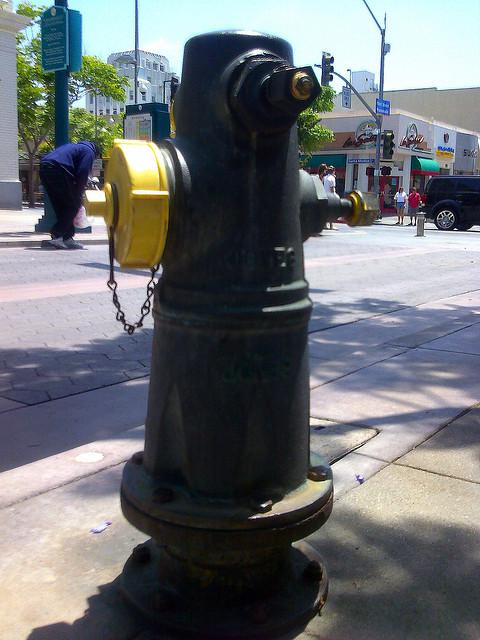What is inside the green and yellow object on the sidewalk? Please explain your reasoning. water. A dark colored hydrant can be seen where someone can open it to put out fires. 